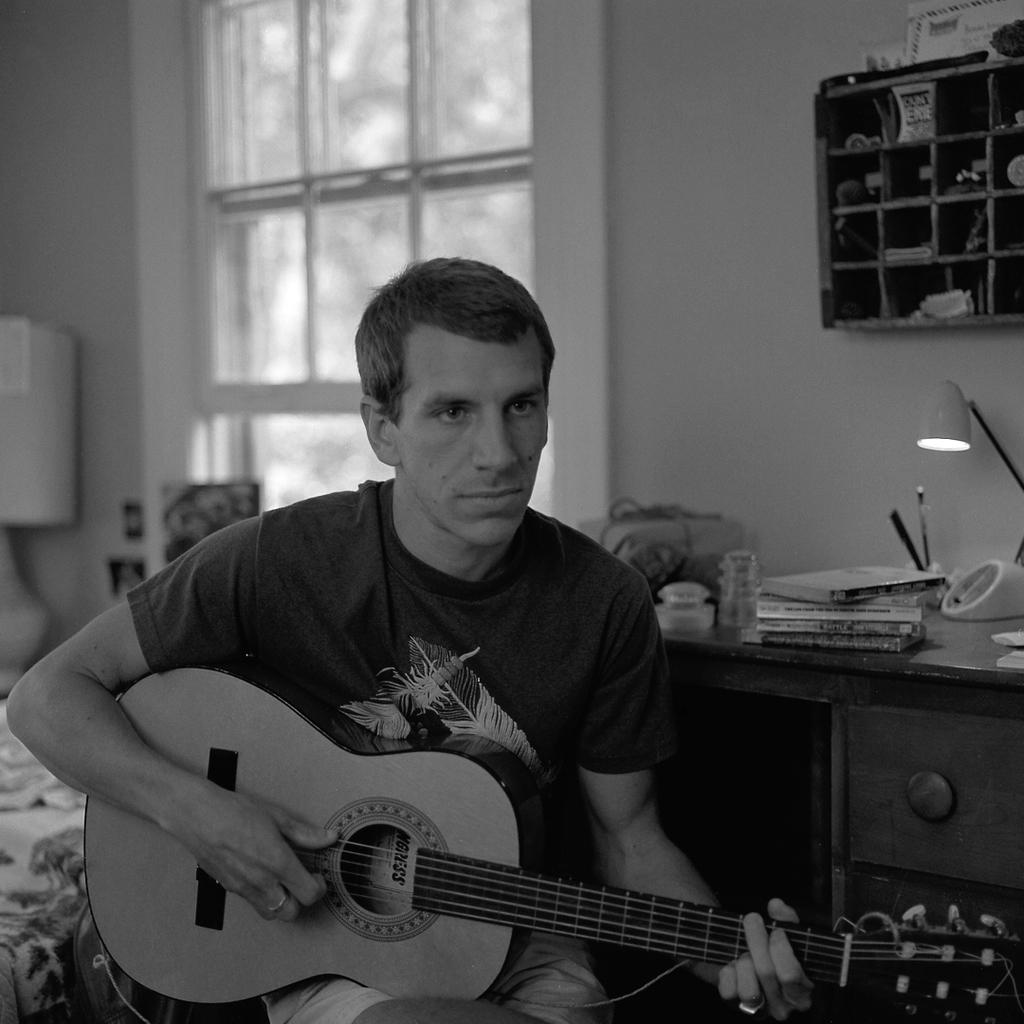What is the man in the image doing? The man is playing guitar. What is the man wearing? The man is wearing a T-shirt. What can be seen on the table in the image? There are books, a lamp, and other items on the table. What is visible in the background of the image? There is a bed and a window in the background. What type of arch can be seen in the image? There is no arch present in the image. How many cups are visible on the table in the image? There is no mention of cups in the image; only books, a lamp, and other items are visible on the table. 